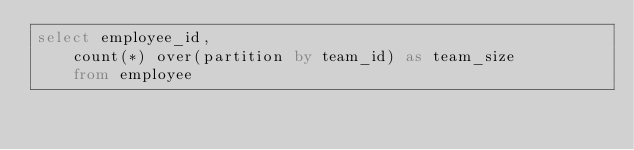Convert code to text. <code><loc_0><loc_0><loc_500><loc_500><_SQL_>select employee_id, 
    count(*) over(partition by team_id) as team_size
    from employee
</code> 